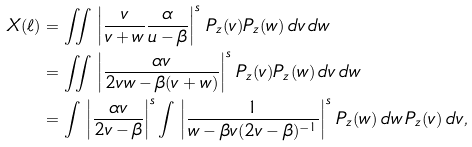Convert formula to latex. <formula><loc_0><loc_0><loc_500><loc_500>X ( \ell ) & = \iint \, \left | \frac { v } { v + w } \frac { \alpha } { u - \beta } \right | ^ { s } \, P _ { z } ( v ) P _ { z } ( w ) \, d v \, d w \\ & = \iint \, \left | \frac { \alpha v } { 2 v w - \beta ( v + w ) } \right | ^ { s } \, P _ { z } ( v ) P _ { z } ( w ) \, d v \, d w \\ & = \int \, \left | \frac { \alpha v } { 2 v - \beta } \right | ^ { s } \int \, \left | \frac { 1 } { w - \beta v ( 2 v - \beta ) ^ { - 1 } } \right | ^ { s } \, P _ { z } ( w ) \, d w \, P _ { z } ( v ) \, d v ,</formula> 